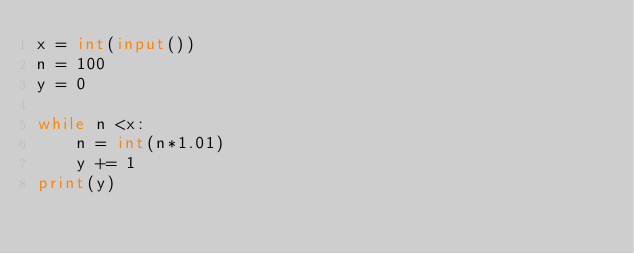Convert code to text. <code><loc_0><loc_0><loc_500><loc_500><_Python_>x = int(input())
n = 100
y = 0

while n <x:
    n = int(n*1.01)
    y += 1
print(y)</code> 